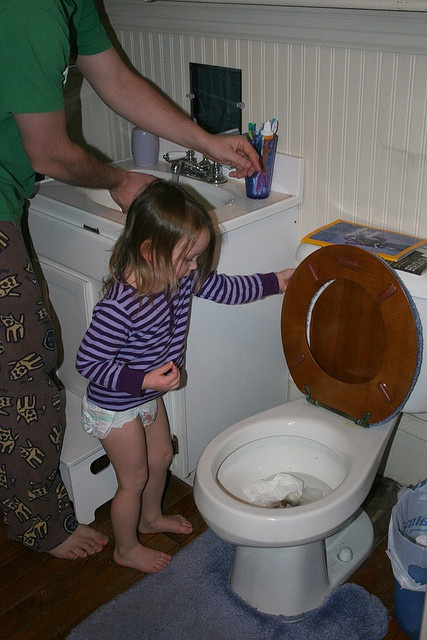Describe the objects in this image and their specific colors. I can see toilet in darkgreen, darkgray, maroon, gray, and black tones, people in darkgreen, black, gray, and maroon tones, people in darkgreen, black, gray, and maroon tones, sink in darkgreen, gray, and black tones, and chair in darkgreen, gray, and black tones in this image. 